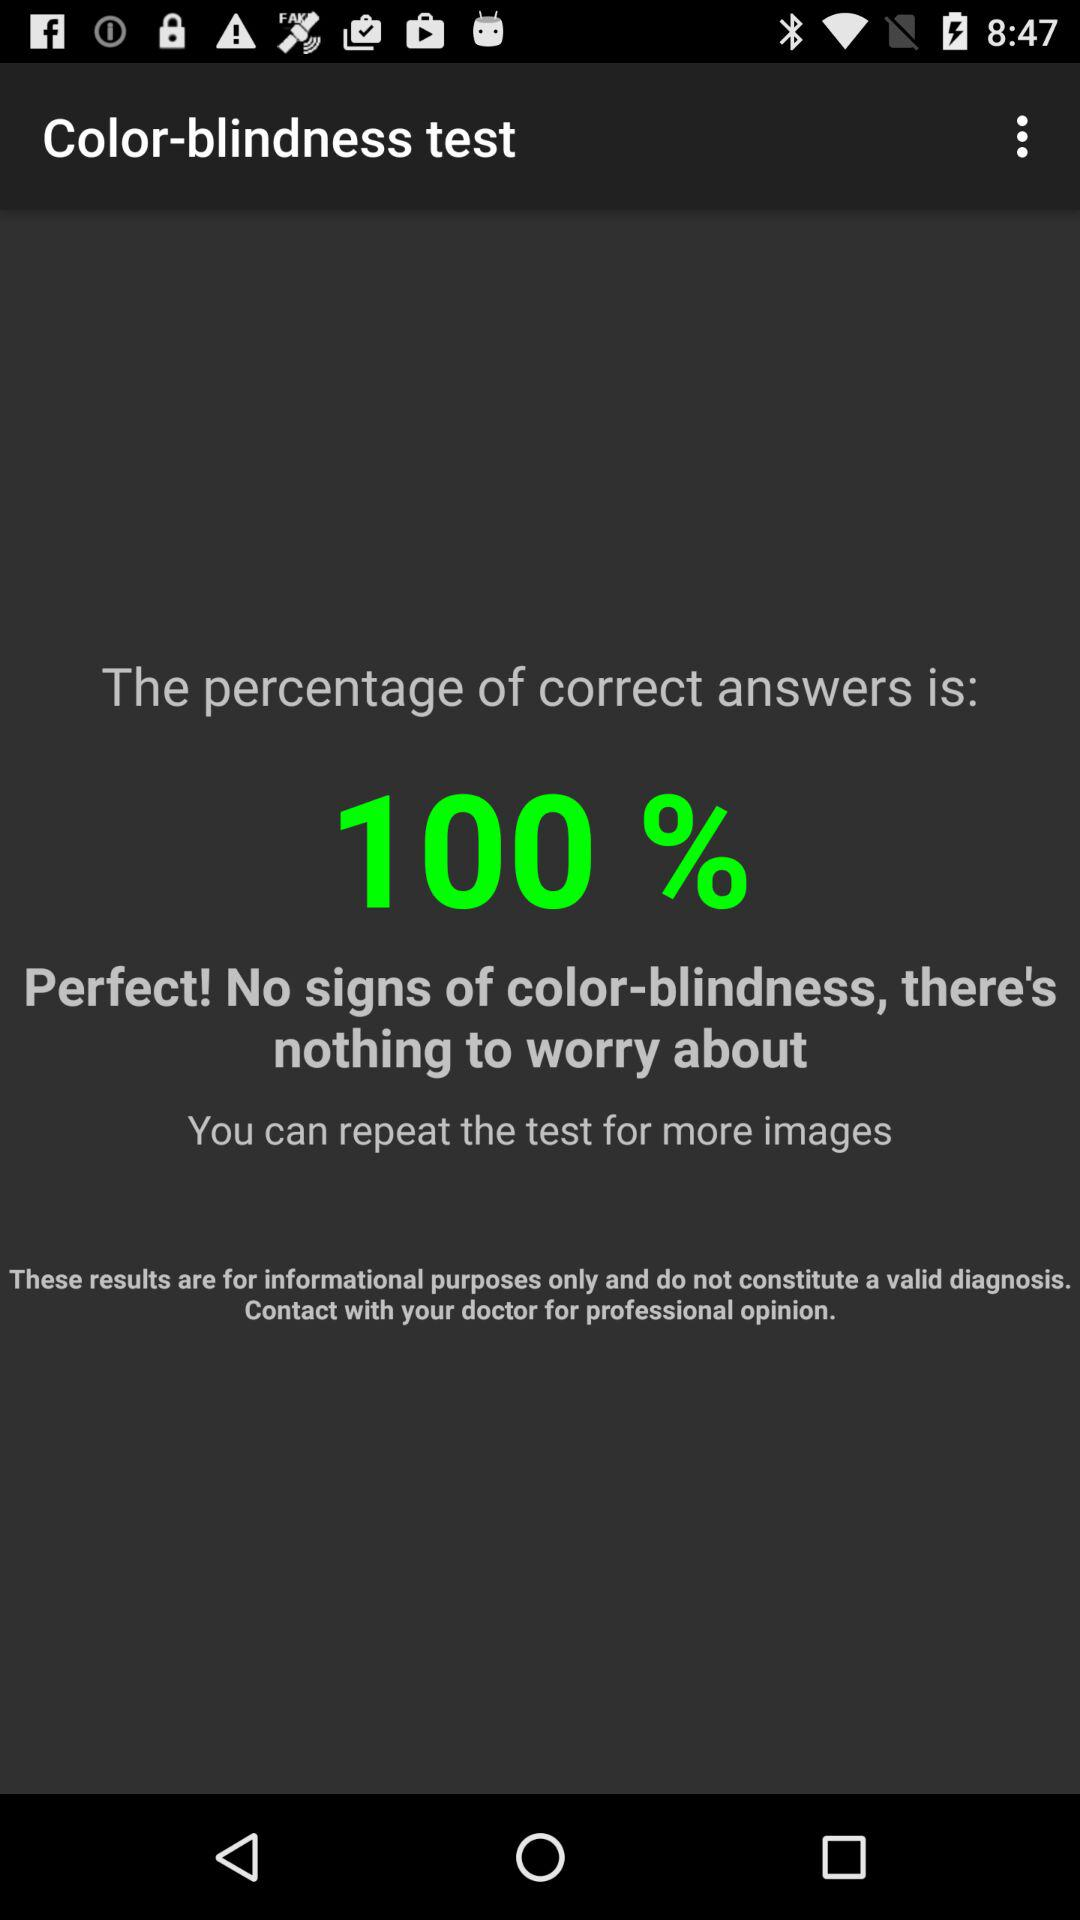What is the percentage of correct answers?
Answer the question using a single word or phrase. 100% 